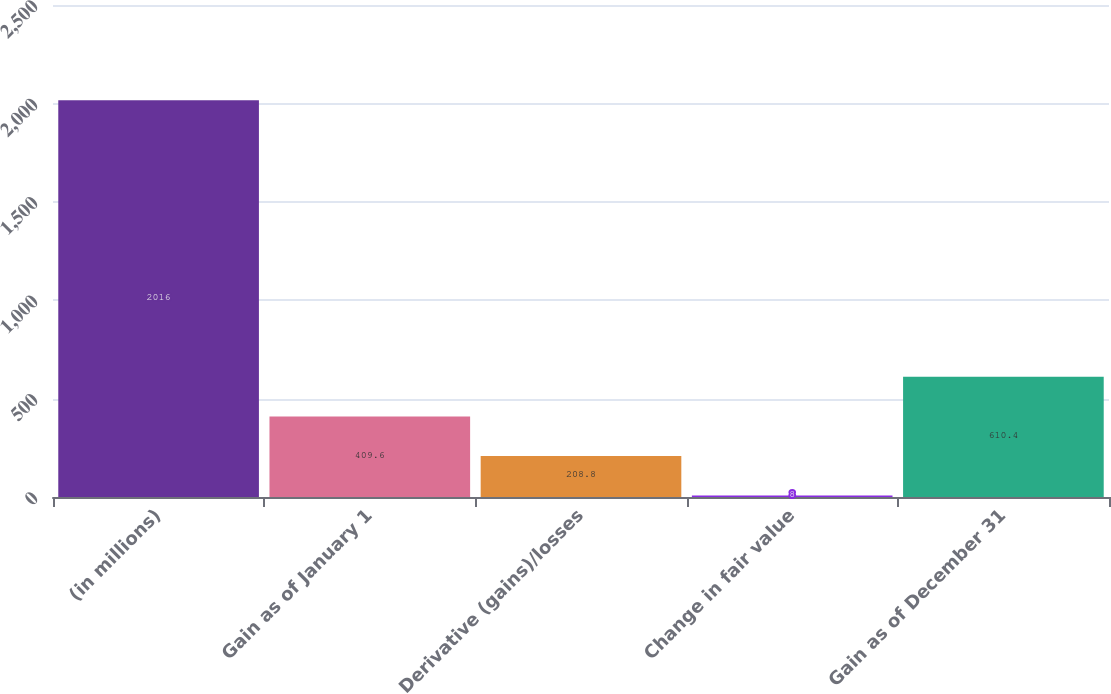Convert chart to OTSL. <chart><loc_0><loc_0><loc_500><loc_500><bar_chart><fcel>(in millions)<fcel>Gain as of January 1<fcel>Derivative (gains)/losses<fcel>Change in fair value<fcel>Gain as of December 31<nl><fcel>2016<fcel>409.6<fcel>208.8<fcel>8<fcel>610.4<nl></chart> 